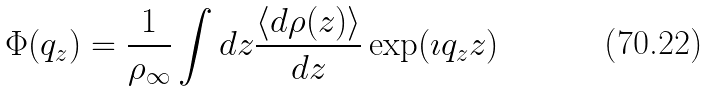Convert formula to latex. <formula><loc_0><loc_0><loc_500><loc_500>\Phi ( q _ { z } ) = \frac { 1 } { \rho _ { \infty } } \int d z \frac { \left < d \rho ( z ) \right > } { d z } \exp ( \imath q _ { z } z )</formula> 